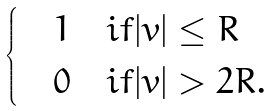<formula> <loc_0><loc_0><loc_500><loc_500>\begin{cases} & 1 \quad i f | v | \leq R \\ & 0 \quad i f | v | > 2 R . \end{cases}</formula> 